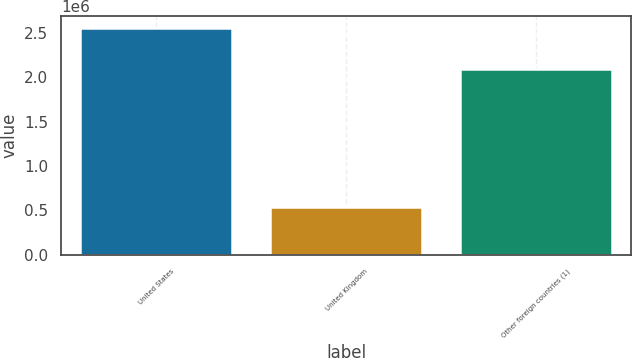Convert chart to OTSL. <chart><loc_0><loc_0><loc_500><loc_500><bar_chart><fcel>United States<fcel>United Kingdom<fcel>Other foreign countries (1)<nl><fcel>2.56034e+06<fcel>542244<fcel>2.09678e+06<nl></chart> 